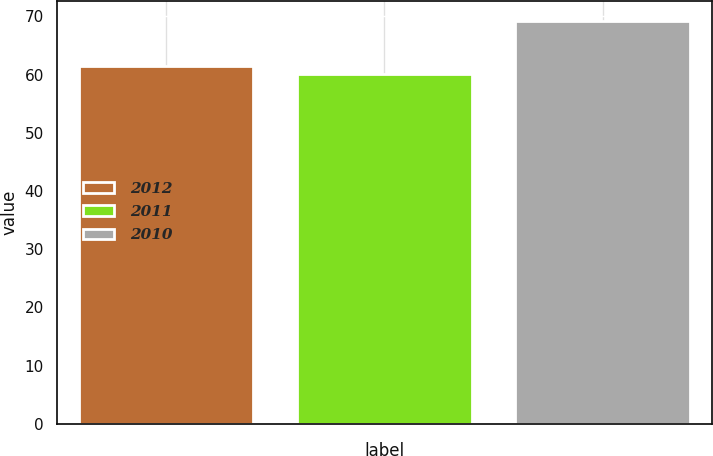Convert chart. <chart><loc_0><loc_0><loc_500><loc_500><bar_chart><fcel>2012<fcel>2011<fcel>2010<nl><fcel>61.55<fcel>60.04<fcel>69.24<nl></chart> 